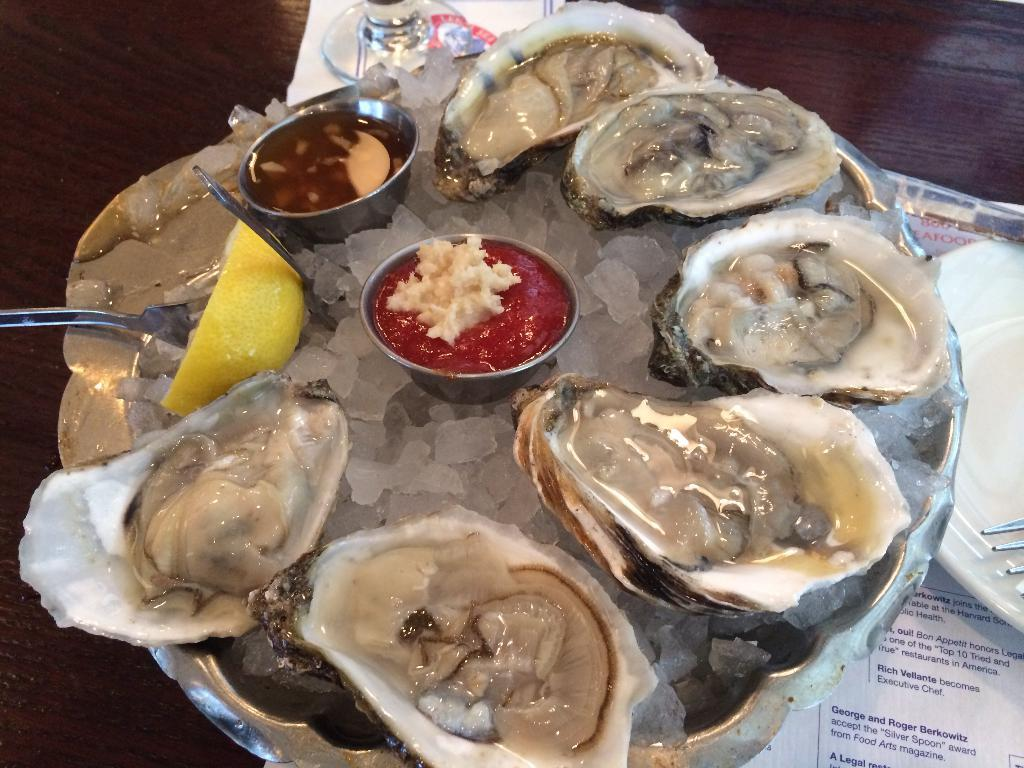What piece of furniture is present in the image? There is a table in the image. What is placed on the table? There are plates and spoons on the table. What type of food can be seen in the image? There are ice cubes and oysters in the image, as well as other food items. How many fairies are sitting at the table in the image? There are no fairies present in the image. What color is the son's shirt in the image? There is no son or shirt mentioned in the provided facts, so we cannot answer this question. 